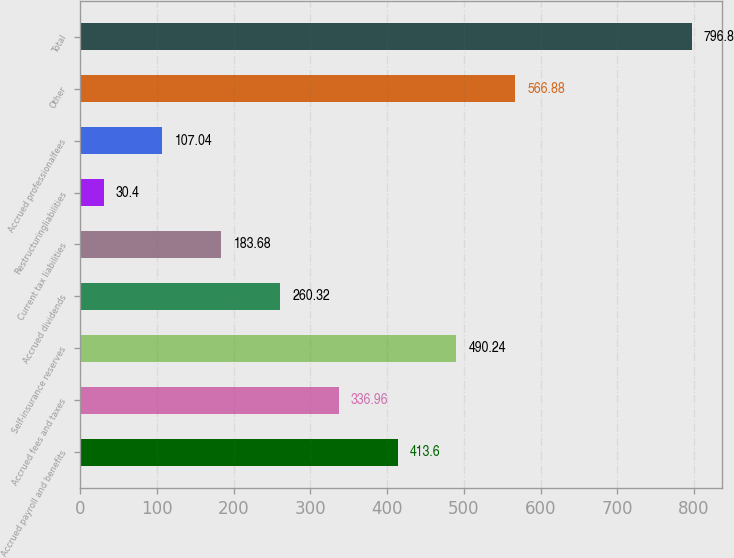<chart> <loc_0><loc_0><loc_500><loc_500><bar_chart><fcel>Accrued payroll and benefits<fcel>Accrued fees and taxes<fcel>Self-insurance reserves<fcel>Accrued dividends<fcel>Current tax liabilities<fcel>Restructuringliabilities<fcel>Accrued professionalfees<fcel>Other<fcel>Total<nl><fcel>413.6<fcel>336.96<fcel>490.24<fcel>260.32<fcel>183.68<fcel>30.4<fcel>107.04<fcel>566.88<fcel>796.8<nl></chart> 